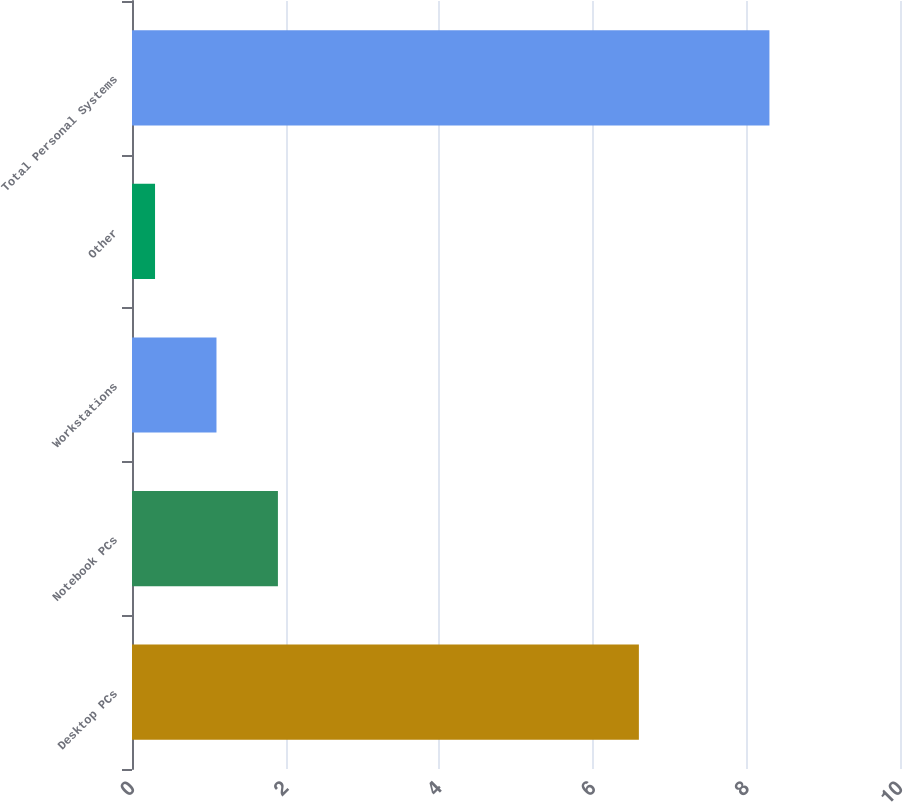Convert chart to OTSL. <chart><loc_0><loc_0><loc_500><loc_500><bar_chart><fcel>Desktop PCs<fcel>Notebook PCs<fcel>Workstations<fcel>Other<fcel>Total Personal Systems<nl><fcel>6.6<fcel>1.9<fcel>1.1<fcel>0.3<fcel>8.3<nl></chart> 